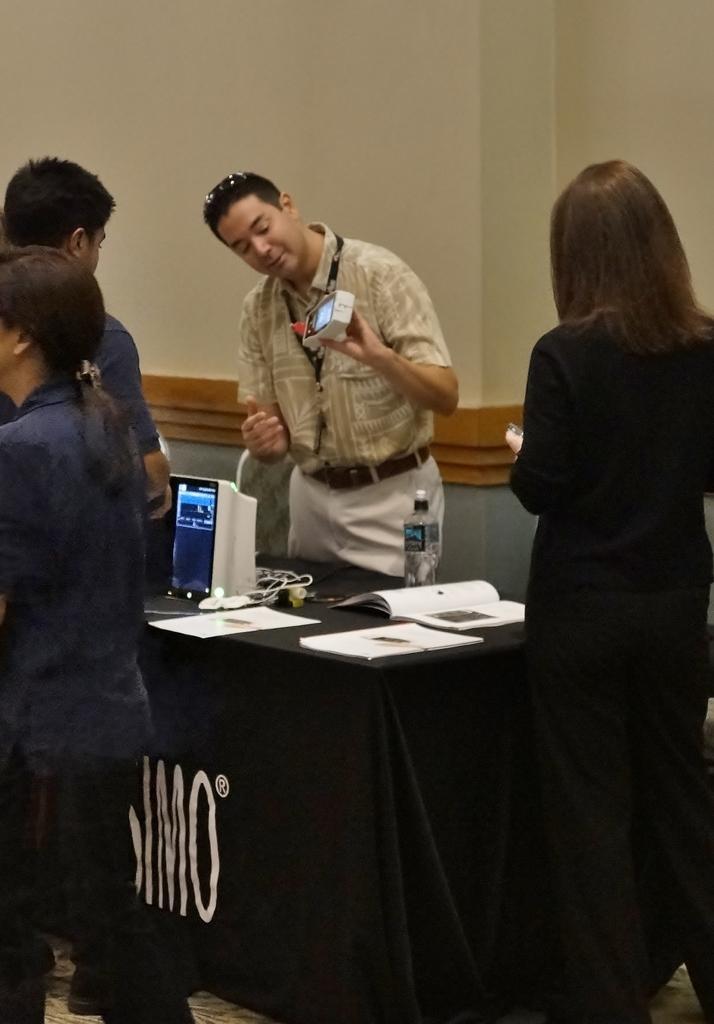In one or two sentences, can you explain what this image depicts? In this picture, we see a man showing a machine to the audience who is standing in front of him. 